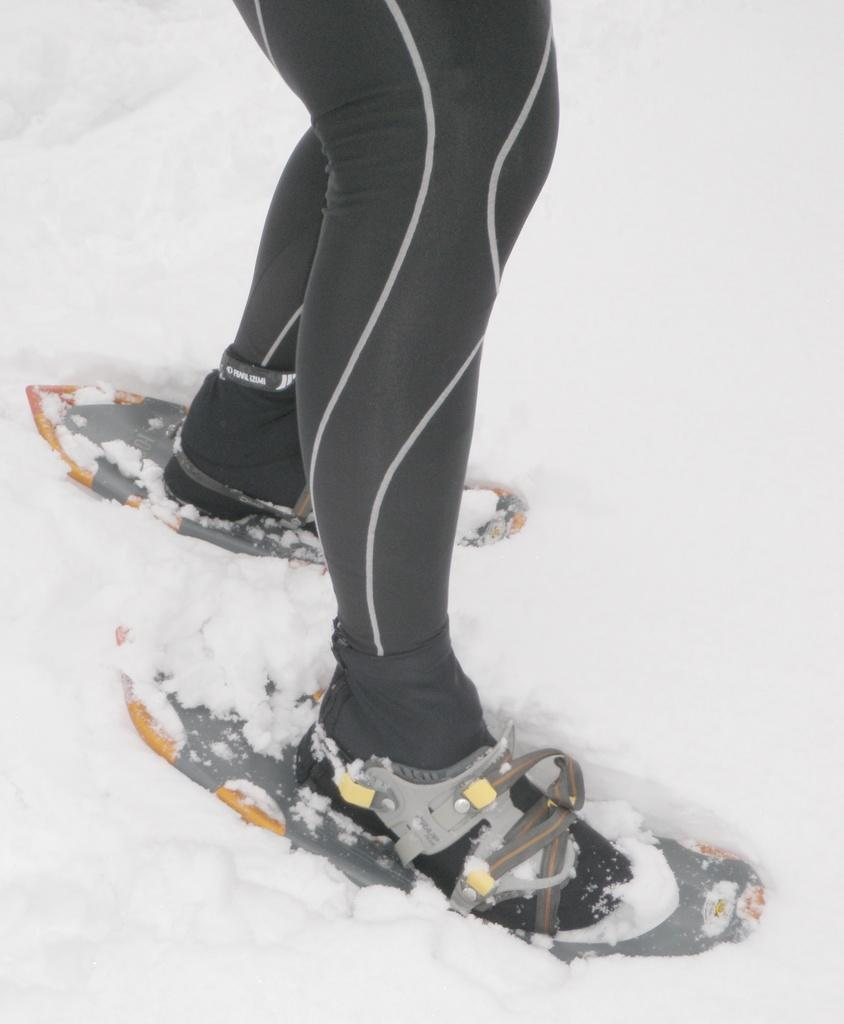What is the main subject of the image? The main subject of the image is a person. What is the person wearing in the image? The person is wearing ice skating boards. Where is the person standing in the image? The person is standing on a snow land. Can you see any horns on the person in the image? There are no horns visible on the person in the image. What type of knowledge is the person demonstrating in the image? The image does not provide any information about the person's knowledge or expertise. 